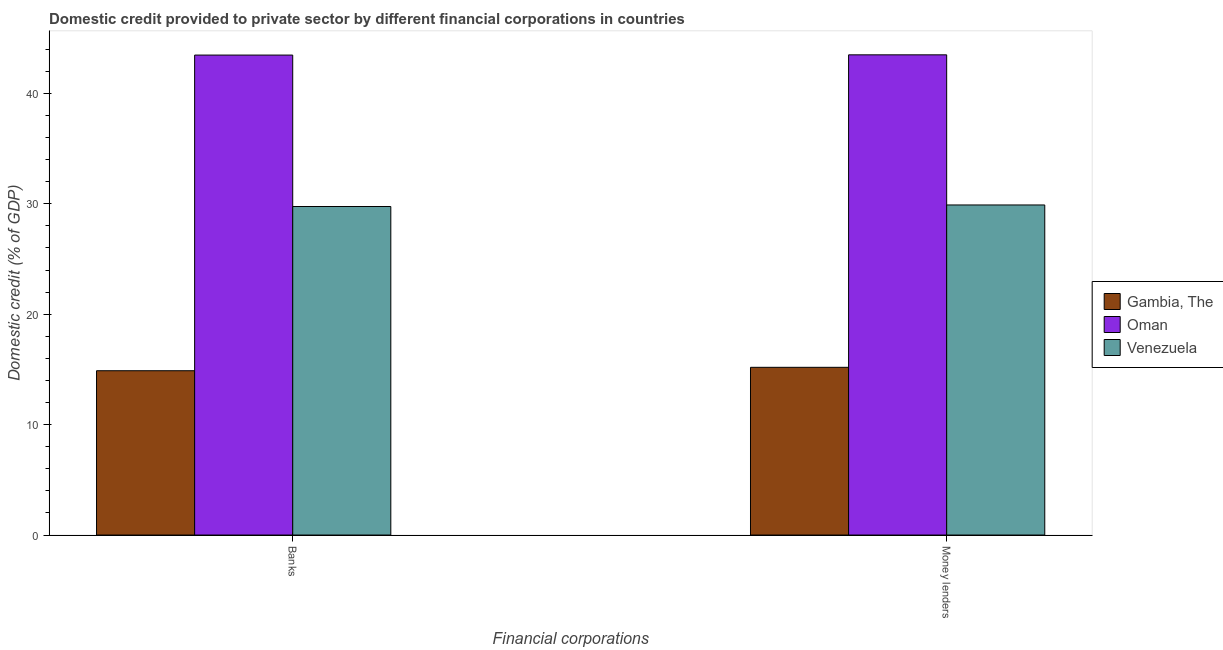How many different coloured bars are there?
Your response must be concise. 3. How many groups of bars are there?
Your response must be concise. 2. What is the label of the 2nd group of bars from the left?
Offer a terse response. Money lenders. What is the domestic credit provided by banks in Venezuela?
Offer a terse response. 29.76. Across all countries, what is the maximum domestic credit provided by banks?
Ensure brevity in your answer.  43.47. Across all countries, what is the minimum domestic credit provided by money lenders?
Your answer should be very brief. 15.19. In which country was the domestic credit provided by money lenders maximum?
Your response must be concise. Oman. In which country was the domestic credit provided by banks minimum?
Your answer should be very brief. Gambia, The. What is the total domestic credit provided by money lenders in the graph?
Offer a terse response. 88.58. What is the difference between the domestic credit provided by banks in Gambia, The and that in Oman?
Offer a very short reply. -28.59. What is the difference between the domestic credit provided by banks in Gambia, The and the domestic credit provided by money lenders in Venezuela?
Offer a very short reply. -15.01. What is the average domestic credit provided by money lenders per country?
Offer a terse response. 29.53. What is the difference between the domestic credit provided by banks and domestic credit provided by money lenders in Oman?
Provide a succinct answer. -0.02. In how many countries, is the domestic credit provided by money lenders greater than 6 %?
Your answer should be compact. 3. What is the ratio of the domestic credit provided by money lenders in Gambia, The to that in Venezuela?
Ensure brevity in your answer.  0.51. Is the domestic credit provided by money lenders in Venezuela less than that in Oman?
Your answer should be compact. Yes. What does the 3rd bar from the left in Banks represents?
Give a very brief answer. Venezuela. What does the 2nd bar from the right in Money lenders represents?
Offer a terse response. Oman. Are all the bars in the graph horizontal?
Ensure brevity in your answer.  No. What is the difference between two consecutive major ticks on the Y-axis?
Offer a terse response. 10. Are the values on the major ticks of Y-axis written in scientific E-notation?
Offer a very short reply. No. Where does the legend appear in the graph?
Offer a very short reply. Center right. How many legend labels are there?
Provide a short and direct response. 3. How are the legend labels stacked?
Your answer should be very brief. Vertical. What is the title of the graph?
Give a very brief answer. Domestic credit provided to private sector by different financial corporations in countries. Does "San Marino" appear as one of the legend labels in the graph?
Make the answer very short. No. What is the label or title of the X-axis?
Provide a short and direct response. Financial corporations. What is the label or title of the Y-axis?
Provide a short and direct response. Domestic credit (% of GDP). What is the Domestic credit (% of GDP) in Gambia, The in Banks?
Give a very brief answer. 14.88. What is the Domestic credit (% of GDP) in Oman in Banks?
Ensure brevity in your answer.  43.47. What is the Domestic credit (% of GDP) in Venezuela in Banks?
Make the answer very short. 29.76. What is the Domestic credit (% of GDP) of Gambia, The in Money lenders?
Offer a very short reply. 15.19. What is the Domestic credit (% of GDP) of Oman in Money lenders?
Provide a succinct answer. 43.49. What is the Domestic credit (% of GDP) of Venezuela in Money lenders?
Your answer should be compact. 29.9. Across all Financial corporations, what is the maximum Domestic credit (% of GDP) of Gambia, The?
Keep it short and to the point. 15.19. Across all Financial corporations, what is the maximum Domestic credit (% of GDP) of Oman?
Offer a very short reply. 43.49. Across all Financial corporations, what is the maximum Domestic credit (% of GDP) in Venezuela?
Your answer should be very brief. 29.9. Across all Financial corporations, what is the minimum Domestic credit (% of GDP) in Gambia, The?
Keep it short and to the point. 14.88. Across all Financial corporations, what is the minimum Domestic credit (% of GDP) of Oman?
Give a very brief answer. 43.47. Across all Financial corporations, what is the minimum Domestic credit (% of GDP) of Venezuela?
Provide a succinct answer. 29.76. What is the total Domestic credit (% of GDP) in Gambia, The in the graph?
Your answer should be very brief. 30.07. What is the total Domestic credit (% of GDP) of Oman in the graph?
Offer a very short reply. 86.97. What is the total Domestic credit (% of GDP) in Venezuela in the graph?
Keep it short and to the point. 59.65. What is the difference between the Domestic credit (% of GDP) in Gambia, The in Banks and that in Money lenders?
Provide a succinct answer. -0.31. What is the difference between the Domestic credit (% of GDP) of Oman in Banks and that in Money lenders?
Keep it short and to the point. -0.02. What is the difference between the Domestic credit (% of GDP) in Venezuela in Banks and that in Money lenders?
Give a very brief answer. -0.14. What is the difference between the Domestic credit (% of GDP) of Gambia, The in Banks and the Domestic credit (% of GDP) of Oman in Money lenders?
Provide a succinct answer. -28.61. What is the difference between the Domestic credit (% of GDP) of Gambia, The in Banks and the Domestic credit (% of GDP) of Venezuela in Money lenders?
Provide a succinct answer. -15.01. What is the difference between the Domestic credit (% of GDP) in Oman in Banks and the Domestic credit (% of GDP) in Venezuela in Money lenders?
Ensure brevity in your answer.  13.58. What is the average Domestic credit (% of GDP) of Gambia, The per Financial corporations?
Ensure brevity in your answer.  15.04. What is the average Domestic credit (% of GDP) of Oman per Financial corporations?
Keep it short and to the point. 43.48. What is the average Domestic credit (% of GDP) of Venezuela per Financial corporations?
Provide a short and direct response. 29.83. What is the difference between the Domestic credit (% of GDP) of Gambia, The and Domestic credit (% of GDP) of Oman in Banks?
Provide a succinct answer. -28.59. What is the difference between the Domestic credit (% of GDP) of Gambia, The and Domestic credit (% of GDP) of Venezuela in Banks?
Give a very brief answer. -14.87. What is the difference between the Domestic credit (% of GDP) in Oman and Domestic credit (% of GDP) in Venezuela in Banks?
Provide a short and direct response. 13.72. What is the difference between the Domestic credit (% of GDP) in Gambia, The and Domestic credit (% of GDP) in Oman in Money lenders?
Offer a very short reply. -28.3. What is the difference between the Domestic credit (% of GDP) of Gambia, The and Domestic credit (% of GDP) of Venezuela in Money lenders?
Your answer should be compact. -14.7. What is the difference between the Domestic credit (% of GDP) of Oman and Domestic credit (% of GDP) of Venezuela in Money lenders?
Your answer should be very brief. 13.6. What is the ratio of the Domestic credit (% of GDP) of Gambia, The in Banks to that in Money lenders?
Ensure brevity in your answer.  0.98. What is the difference between the highest and the second highest Domestic credit (% of GDP) in Gambia, The?
Your answer should be compact. 0.31. What is the difference between the highest and the second highest Domestic credit (% of GDP) of Oman?
Give a very brief answer. 0.02. What is the difference between the highest and the second highest Domestic credit (% of GDP) of Venezuela?
Provide a short and direct response. 0.14. What is the difference between the highest and the lowest Domestic credit (% of GDP) of Gambia, The?
Your response must be concise. 0.31. What is the difference between the highest and the lowest Domestic credit (% of GDP) in Oman?
Give a very brief answer. 0.02. What is the difference between the highest and the lowest Domestic credit (% of GDP) of Venezuela?
Your answer should be compact. 0.14. 